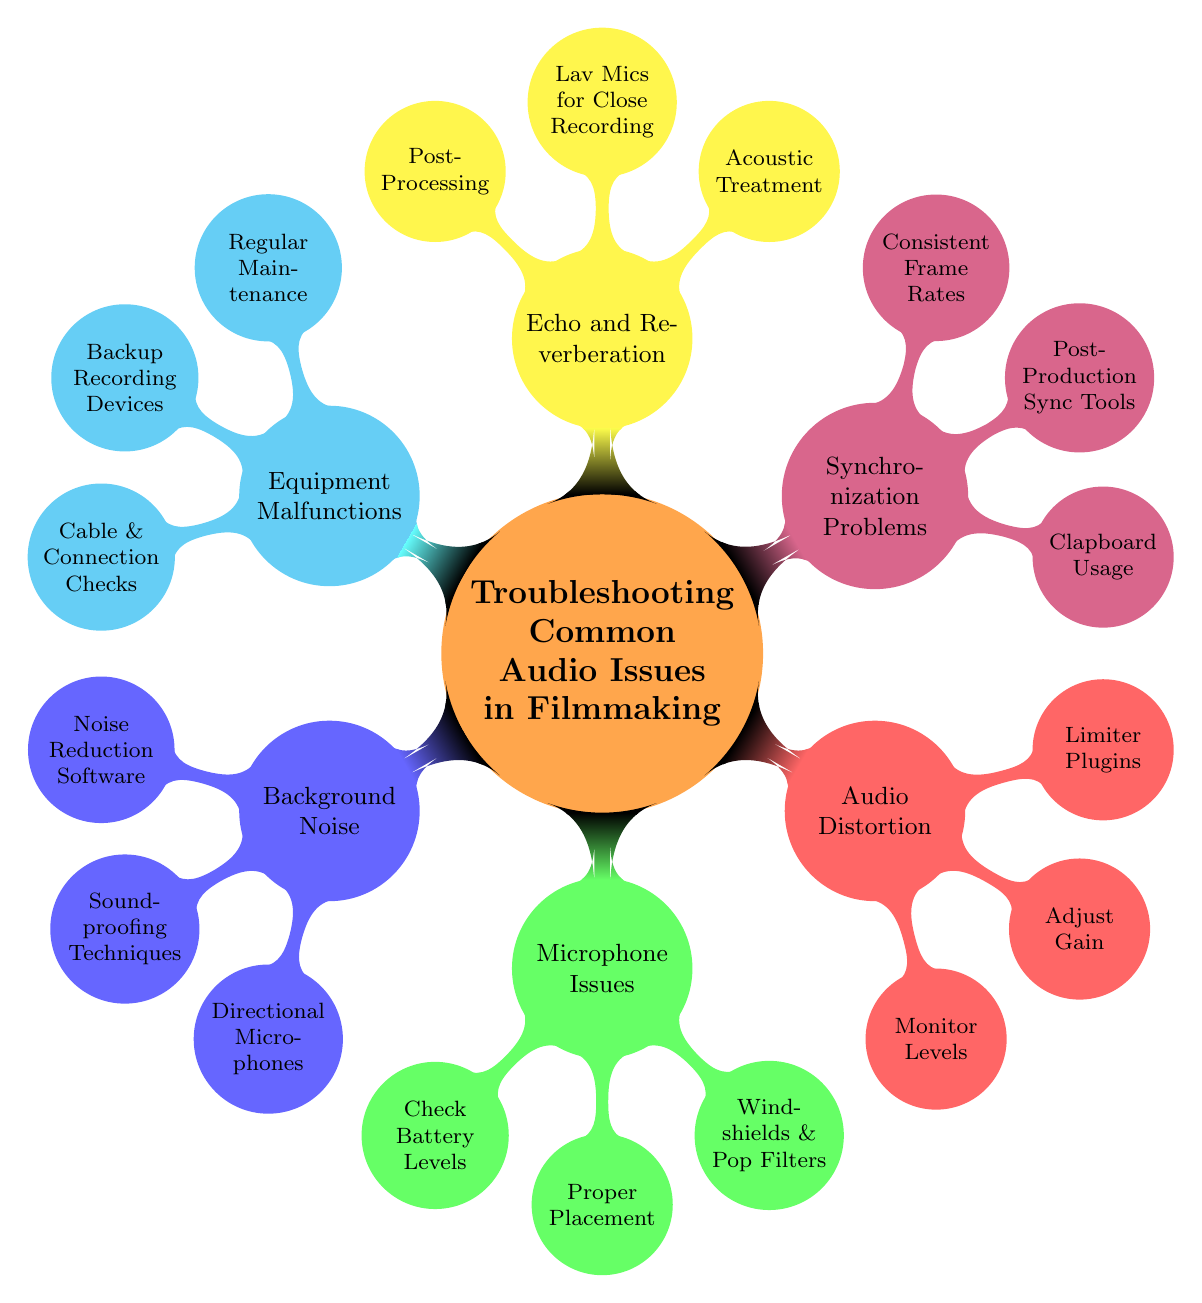What are the main topics in the diagram? The main topics in the diagram are the different categories of audio issues such as Background Noise, Microphone Issues, Audio Distortion, Synchronization Problems, Echo and Reverberation, and Equipment Malfunctions. They can be found as the first level nodes branching from the main topic.
Answer: Background Noise, Microphone Issues, Audio Distortion, Synchronization Problems, Echo and Reverberation, Equipment Malfunctions How many elements are listed under Echo and Reverberation? To find the number of elements under the Echo and Reverberation node, I look at the second-level nodes that are directly connected to it. There are three such elements: Acoustic Treatment, Lav Mics for Close Recording, and Post-Processing.
Answer: 3 What software is recommended for noise reduction? The diagram lists Noise Reduction Software as an element under the Background Noise subtopic. Specific examples are provided in the node, including Adobe Audition and iZotope RX.
Answer: Noise Reduction Software (e.g., Adobe Audition, iZotope RX) Which audio issue subtopic includes the use of clapboards? The clapboard is specifically mentioned under the Synchronization Problems subtopic, indicating its relevance in addressing sync issues during editing.
Answer: Synchronization Problems How many techniques are mentioned for addressing microphone issues? Under the Microphone Issues subtopic, the diagram includes three techniques: Check Battery Levels, Proper Placement, and using Windshields and Pop Filters. This count can be obtained by counting the second-level nodes connected to the Microphone Issues node.
Answer: 3 What should you check for Equipment Malfunctions? The Equipment Malfunctions subtopic includes three elements: Regular Equipment Maintenance, Backup Audio Recording Devices, and Cable and Connection Checks. This can be deduced by examining the components listed under this specific subtopic.
Answer: Regular Equipment Maintenance, Backup Audio Recording Devices, Cable and Connection Checks Which subtopic suggests using directional microphones to reduce noise? The Background Noise subtopic suggests using Directional Microphones as one of the methods to help mitigate unwanted noise. It can be directly identified as one of the elements under that specific subtopic.
Answer: Background Noise What is the purpose of using limiter plugins? Limiter Plugins are listed under the Audio Distortion subtopic, which implies that their purpose is likely to prevent audio distortion by controlling the levels. This can be inferred from their placement among other techniques aimed at controlling audio quality.
Answer: Audio Distortion 